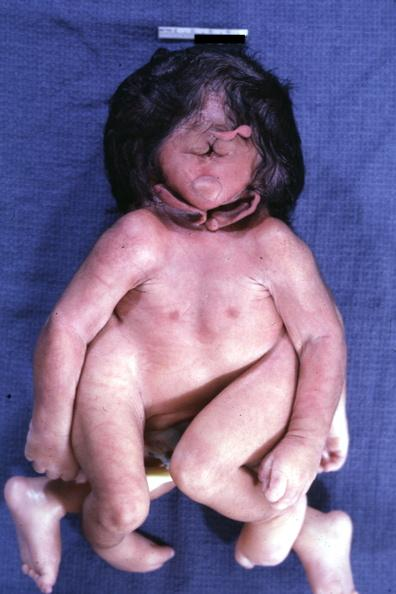what is present?
Answer the question using a single word or phrase. Cephalothoracopagus janiceps 